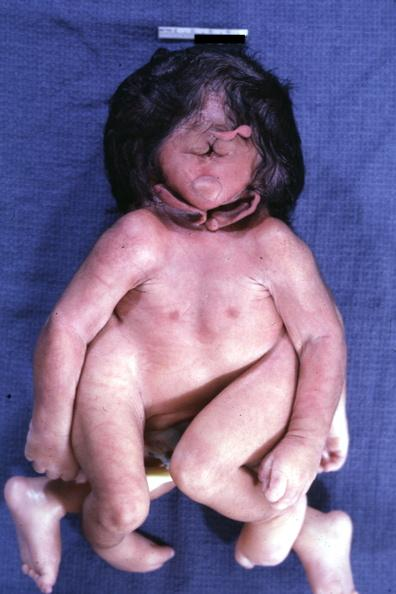what is present?
Answer the question using a single word or phrase. Cephalothoracopagus janiceps 